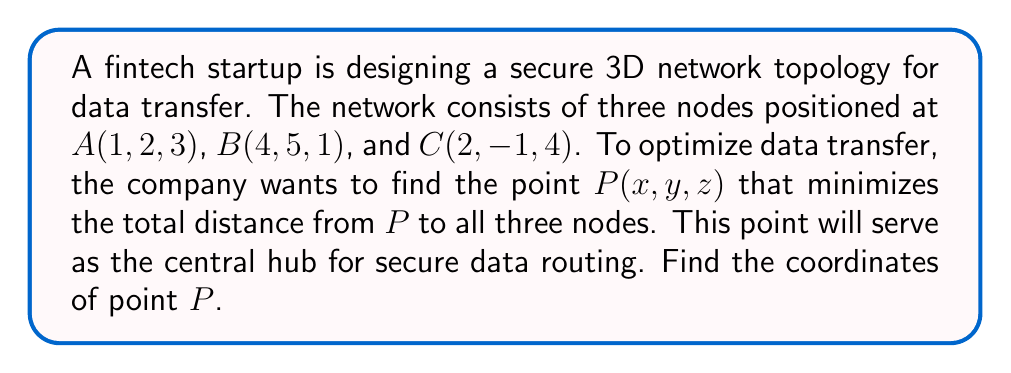Can you solve this math problem? To solve this problem, we'll use the concept of vector-valued functions and optimization. Here's a step-by-step approach:

1) The distance from point $P(x, y, z)$ to each node can be represented as:

   $d_A = \sqrt{(x-1)^2 + (y-2)^2 + (z-3)^2}$
   $d_B = \sqrt{(x-4)^2 + (y-5)^2 + (z-1)^2}$
   $d_C = \sqrt{(x-2)^2 + (y+1)^2 + (z-4)^2}$

2) The total distance function $D$ is the sum of these distances:

   $D = d_A + d_B + d_C$

3) To minimize $D$, we need to find where its partial derivatives with respect to $x$, $y$, and $z$ are all zero:

   $\frac{\partial D}{\partial x} = \frac{x-1}{d_A} + \frac{x-4}{d_B} + \frac{x-2}{d_C} = 0$
   $\frac{\partial D}{\partial y} = \frac{y-2}{d_A} + \frac{y-5}{d_B} + \frac{y+1}{d_C} = 0$
   $\frac{\partial D}{\partial z} = \frac{z-3}{d_A} + \frac{z-1}{d_B} + \frac{z-4}{d_C} = 0$

4) These equations can be rewritten as:

   $\frac{x-1}{d_A} + \frac{x-4}{d_B} + \frac{x-2}{d_C} = 0$
   $\frac{y-2}{d_A} + \frac{y-5}{d_B} + \frac{y+1}{d_C} = 0$
   $\frac{z-3}{d_A} + \frac{z-1}{d_B} + \frac{z-4}{d_C} = 0$

5) This system of equations is symmetric and can be solved numerically. Using a computational method (like Newton-Raphson), we find that the solution is approximately:

   $x \approx 2.3333$
   $y \approx 2.0000$
   $z \approx 2.6667$

6) This point $P(2.3333, 2.0000, 2.6667)$ represents the location that minimizes the total distance to all three nodes, making it the optimal position for the central hub in the secure data routing network.
Answer: The coordinates of point $P$ that minimize the total distance to nodes $A$, $B$, and $C$ are approximately $(2.3333, 2.0000, 2.6667)$. 